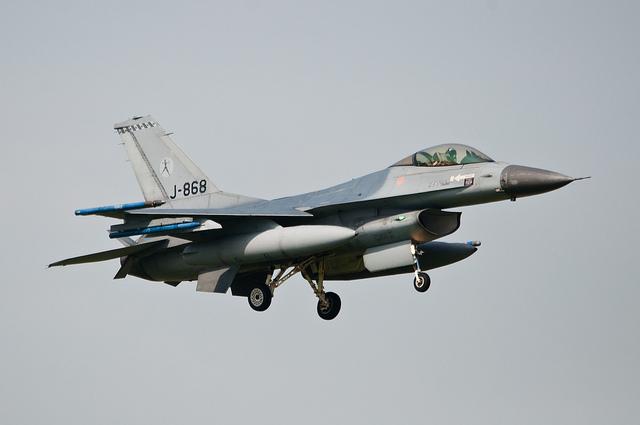How many engines are on the plane?
Keep it brief. 1. What type of fighter jet is this?
Be succinct. J-868. Where is the smaller plane in relation to the larger one?
Answer briefly. No. What color is the plane?
Concise answer only. Gray. What is the number on the plane?
Answer briefly. 868. What is the id number of the plane?
Concise answer only. J-868. How many people are in the plane?
Give a very brief answer. 1. Are the wheels up or down?
Answer briefly. Down. Why is someone on top of the airplane?
Write a very short answer. Flying it. 